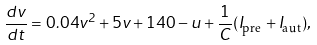<formula> <loc_0><loc_0><loc_500><loc_500>\frac { d v } { d t } = 0 . 0 4 v ^ { 2 } + 5 v + 1 4 0 - u + \frac { 1 } { C } ( { I _ { \text {pre} } + I _ { \text {aut} } } ) ,</formula> 